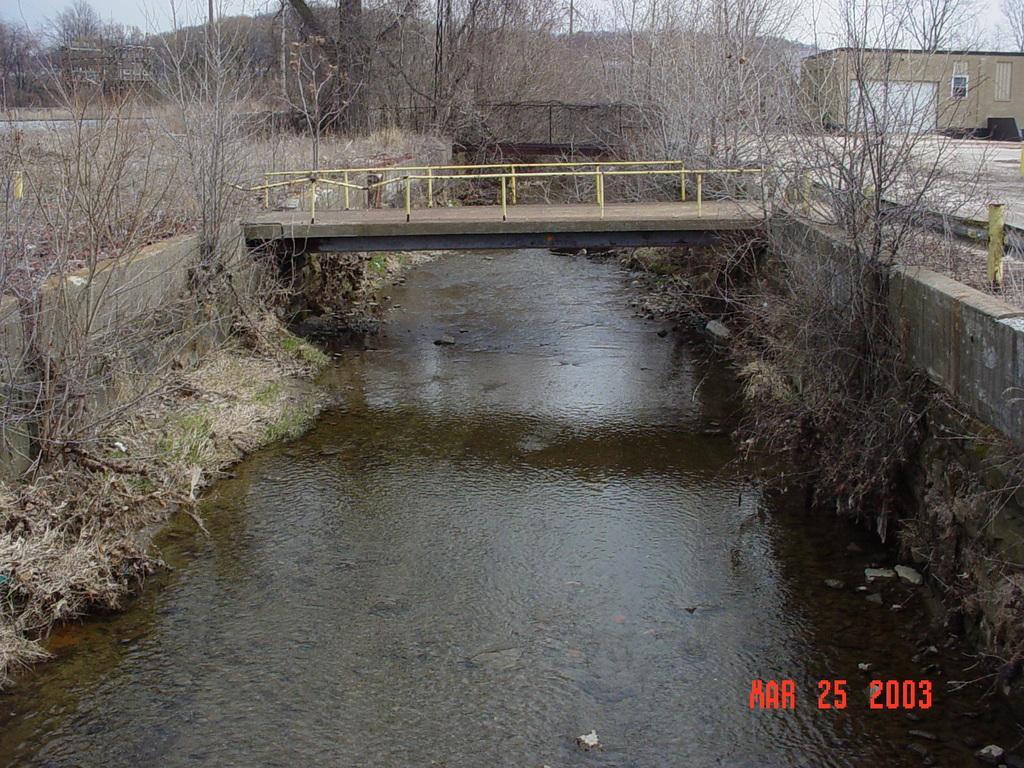How would you summarize this image in a sentence or two? In this picture I can see the bridge. I can see the water. I can see trees. I can see the house on the right side. 